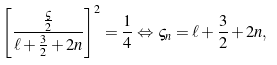Convert formula to latex. <formula><loc_0><loc_0><loc_500><loc_500>\left [ \frac { \frac { \varsigma } { 2 } } { \ell + \frac { 3 } { 2 } + 2 n } \right ] ^ { 2 } = \frac { 1 } { 4 } \Leftrightarrow \varsigma _ { n } = \ell + \frac { 3 } { 2 } + 2 n ,</formula> 